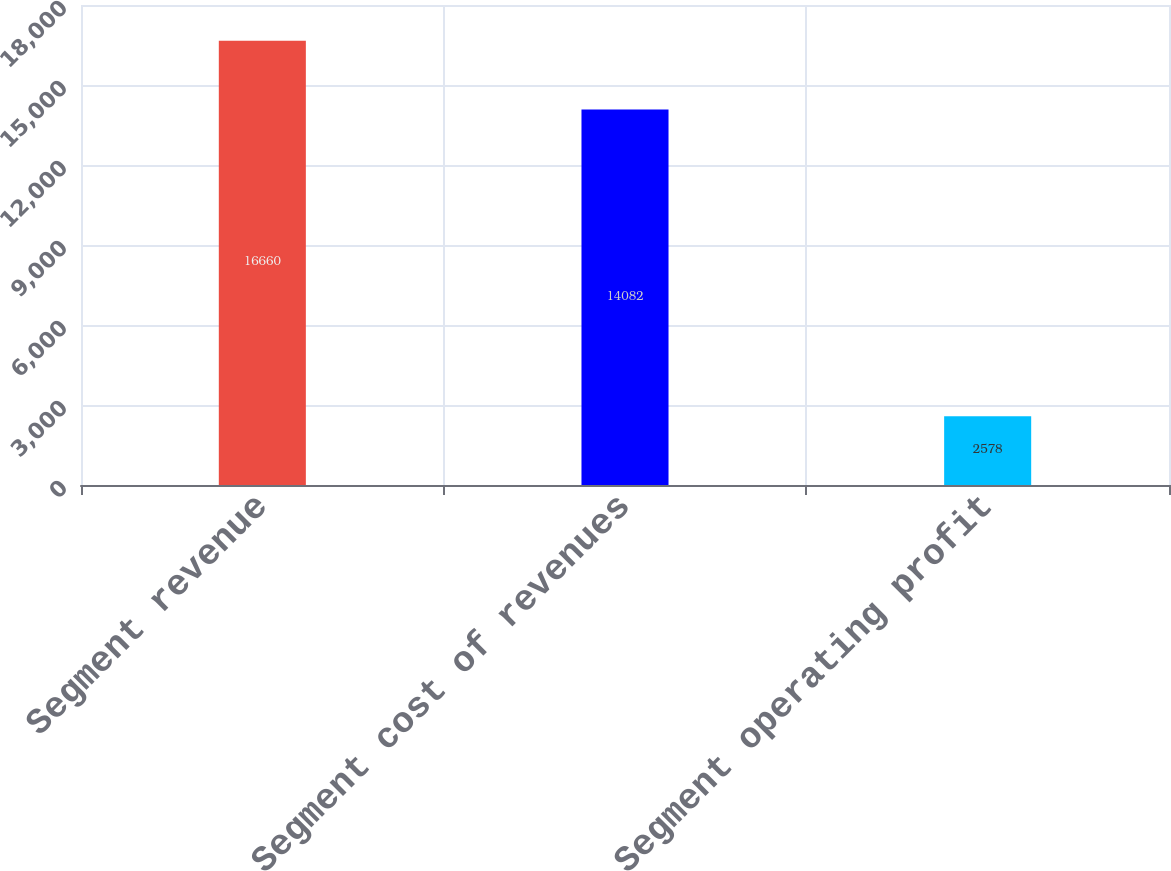<chart> <loc_0><loc_0><loc_500><loc_500><bar_chart><fcel>Segment revenue<fcel>Segment cost of revenues<fcel>Segment operating profit<nl><fcel>16660<fcel>14082<fcel>2578<nl></chart> 